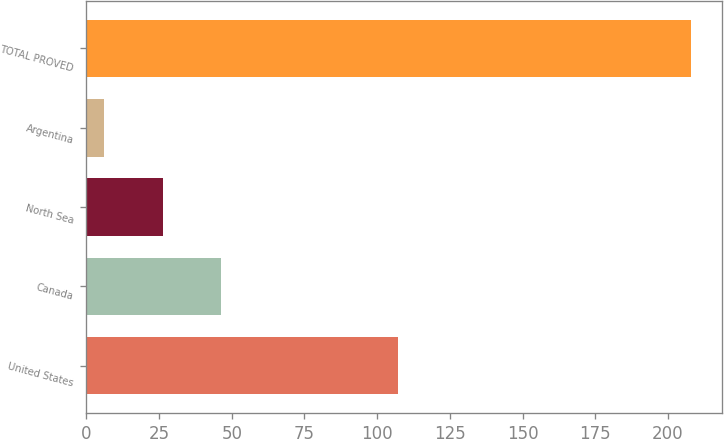Convert chart. <chart><loc_0><loc_0><loc_500><loc_500><bar_chart><fcel>United States<fcel>Canada<fcel>North Sea<fcel>Argentina<fcel>TOTAL PROVED<nl><fcel>107<fcel>46.4<fcel>26.2<fcel>6<fcel>208<nl></chart> 